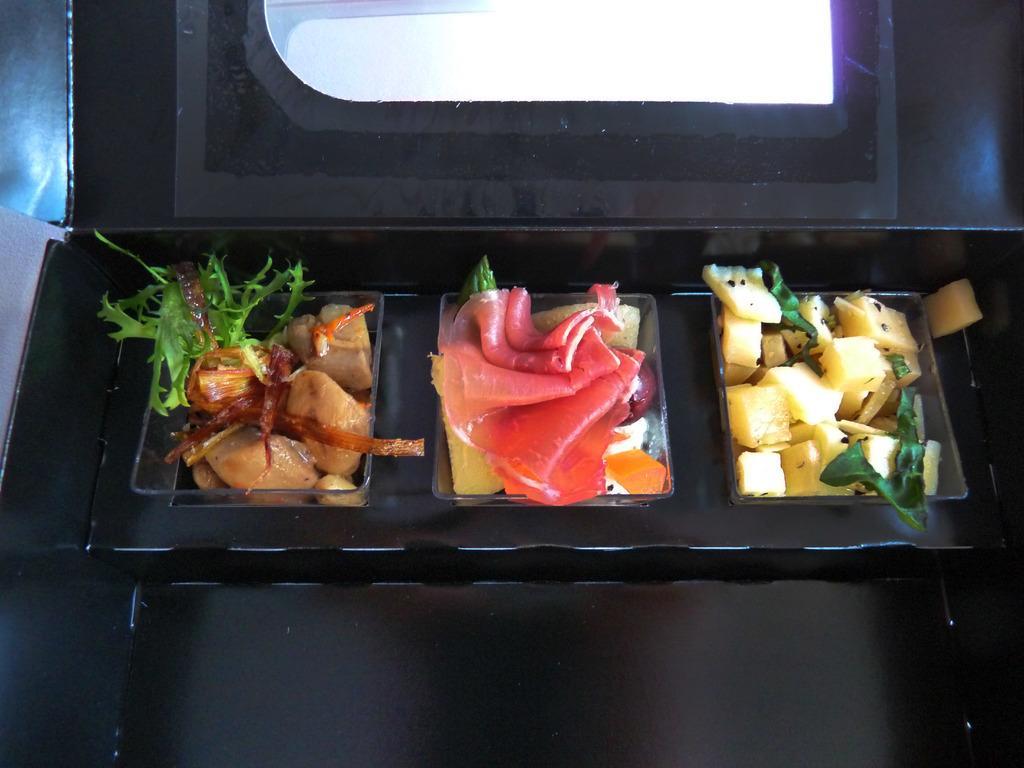Can you describe this image briefly? In this image there are potatoes, meat and salad placed separately inside the box. 